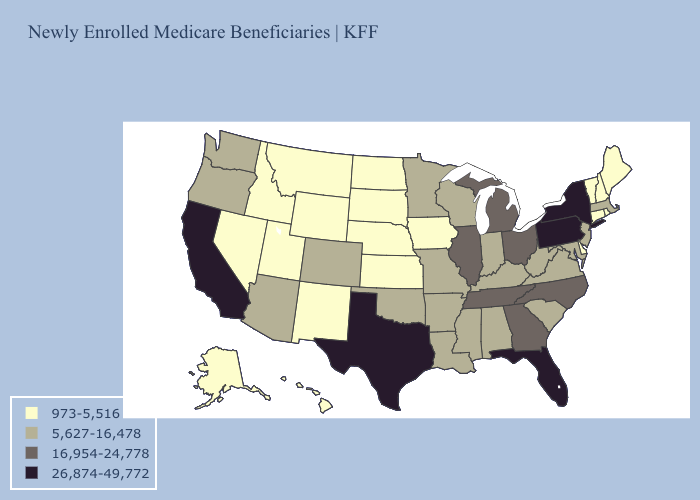Among the states that border Louisiana , does Texas have the lowest value?
Keep it brief. No. Name the states that have a value in the range 16,954-24,778?
Keep it brief. Georgia, Illinois, Michigan, North Carolina, Ohio, Tennessee. Which states have the highest value in the USA?
Be succinct. California, Florida, New York, Pennsylvania, Texas. Name the states that have a value in the range 5,627-16,478?
Give a very brief answer. Alabama, Arizona, Arkansas, Colorado, Indiana, Kentucky, Louisiana, Maryland, Massachusetts, Minnesota, Mississippi, Missouri, New Jersey, Oklahoma, Oregon, South Carolina, Virginia, Washington, West Virginia, Wisconsin. Which states have the highest value in the USA?
Be succinct. California, Florida, New York, Pennsylvania, Texas. Does Tennessee have the lowest value in the USA?
Give a very brief answer. No. Does New Mexico have a lower value than Missouri?
Give a very brief answer. Yes. What is the lowest value in the USA?
Keep it brief. 973-5,516. What is the highest value in the West ?
Be succinct. 26,874-49,772. Name the states that have a value in the range 973-5,516?
Be succinct. Alaska, Connecticut, Delaware, Hawaii, Idaho, Iowa, Kansas, Maine, Montana, Nebraska, Nevada, New Hampshire, New Mexico, North Dakota, Rhode Island, South Dakota, Utah, Vermont, Wyoming. What is the value of Connecticut?
Keep it brief. 973-5,516. What is the value of Arkansas?
Concise answer only. 5,627-16,478. Name the states that have a value in the range 16,954-24,778?
Short answer required. Georgia, Illinois, Michigan, North Carolina, Ohio, Tennessee. How many symbols are there in the legend?
Keep it brief. 4. Does the first symbol in the legend represent the smallest category?
Short answer required. Yes. 